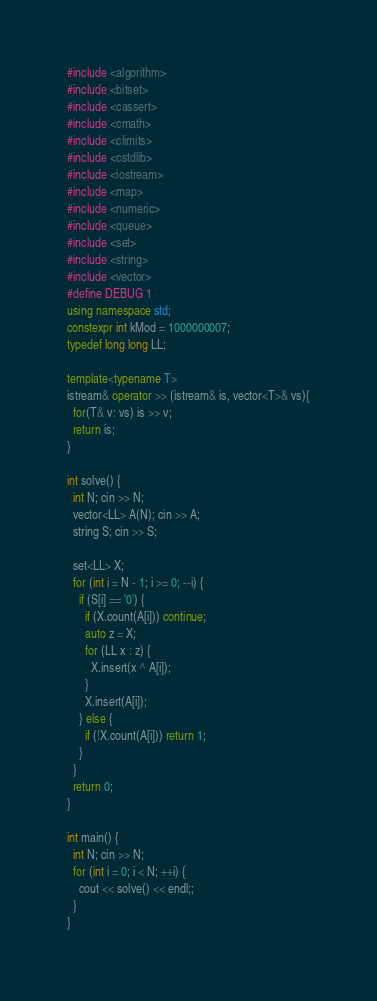<code> <loc_0><loc_0><loc_500><loc_500><_C++_>#include <algorithm>
#include <bitset>
#include <cassert>
#include <cmath>
#include <climits>
#include <cstdlib>
#include <iostream>
#include <map>
#include <numeric>
#include <queue>
#include <set>
#include <string>
#include <vector>
#define DEBUG 1
using namespace std;
constexpr int kMod = 1000000007;
typedef long long LL;

template<typename T>
istream& operator >> (istream& is, vector<T>& vs){
  for(T& v: vs) is >> v;
  return is;
}

int solve() {
  int N; cin >> N;
  vector<LL> A(N); cin >> A;
  string S; cin >> S;

  set<LL> X;
  for (int i = N - 1; i >= 0; --i) {
    if (S[i] == '0') {
      if (X.count(A[i])) continue;
      auto z = X;
      for (LL x : z) {
        X.insert(x ^ A[i]);
      }
      X.insert(A[i]);
    } else {
      if (!X.count(A[i])) return 1;
    }
  }
  return 0;
}

int main() {
  int N; cin >> N;
  for (int i = 0; i < N; ++i) {
    cout << solve() << endl;;
  }
}
</code> 